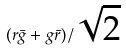Convert formula to latex. <formula><loc_0><loc_0><loc_500><loc_500>( r { \bar { g } } + g { \bar { r } } ) / { \sqrt { 2 } }</formula> 